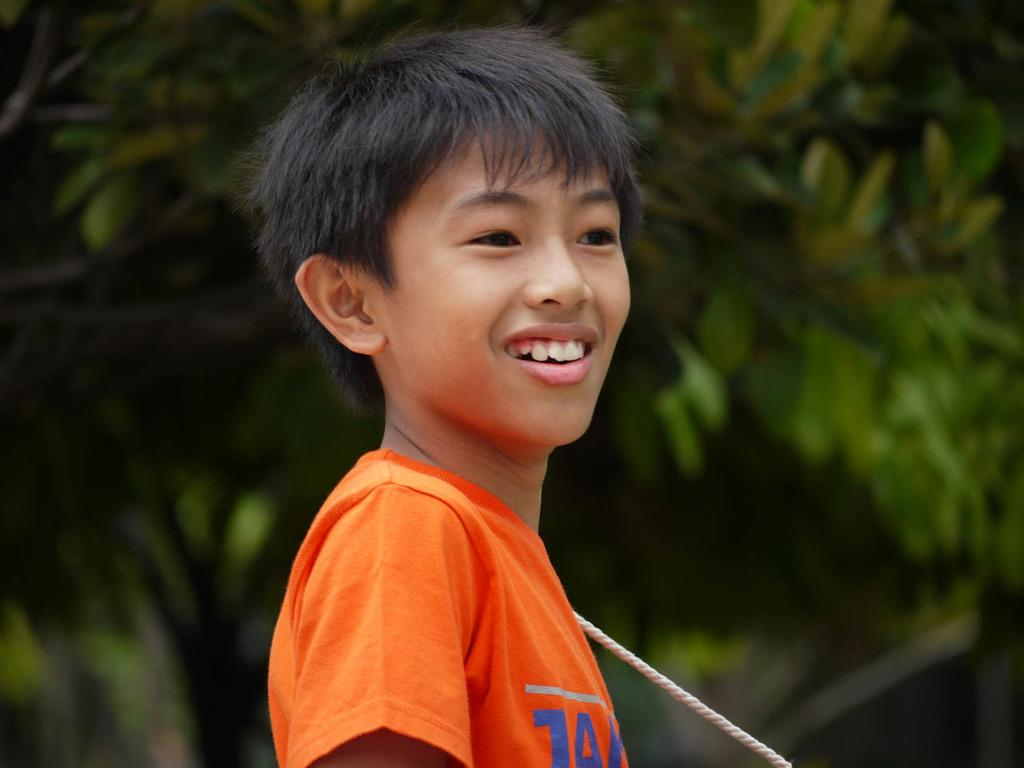Who is the main subject in the image? There is a boy in the image. What is the boy wearing? The boy is wearing an orange t-shirt. What is the boy's facial expression? The boy is smiling. Can you describe any other objects or elements in the image? There is a thread in the image, and trees can be seen in the background. How would you describe the background of the image? The background is blurred. What type of cup is the boy holding in the image? There is no cup present in the image. 